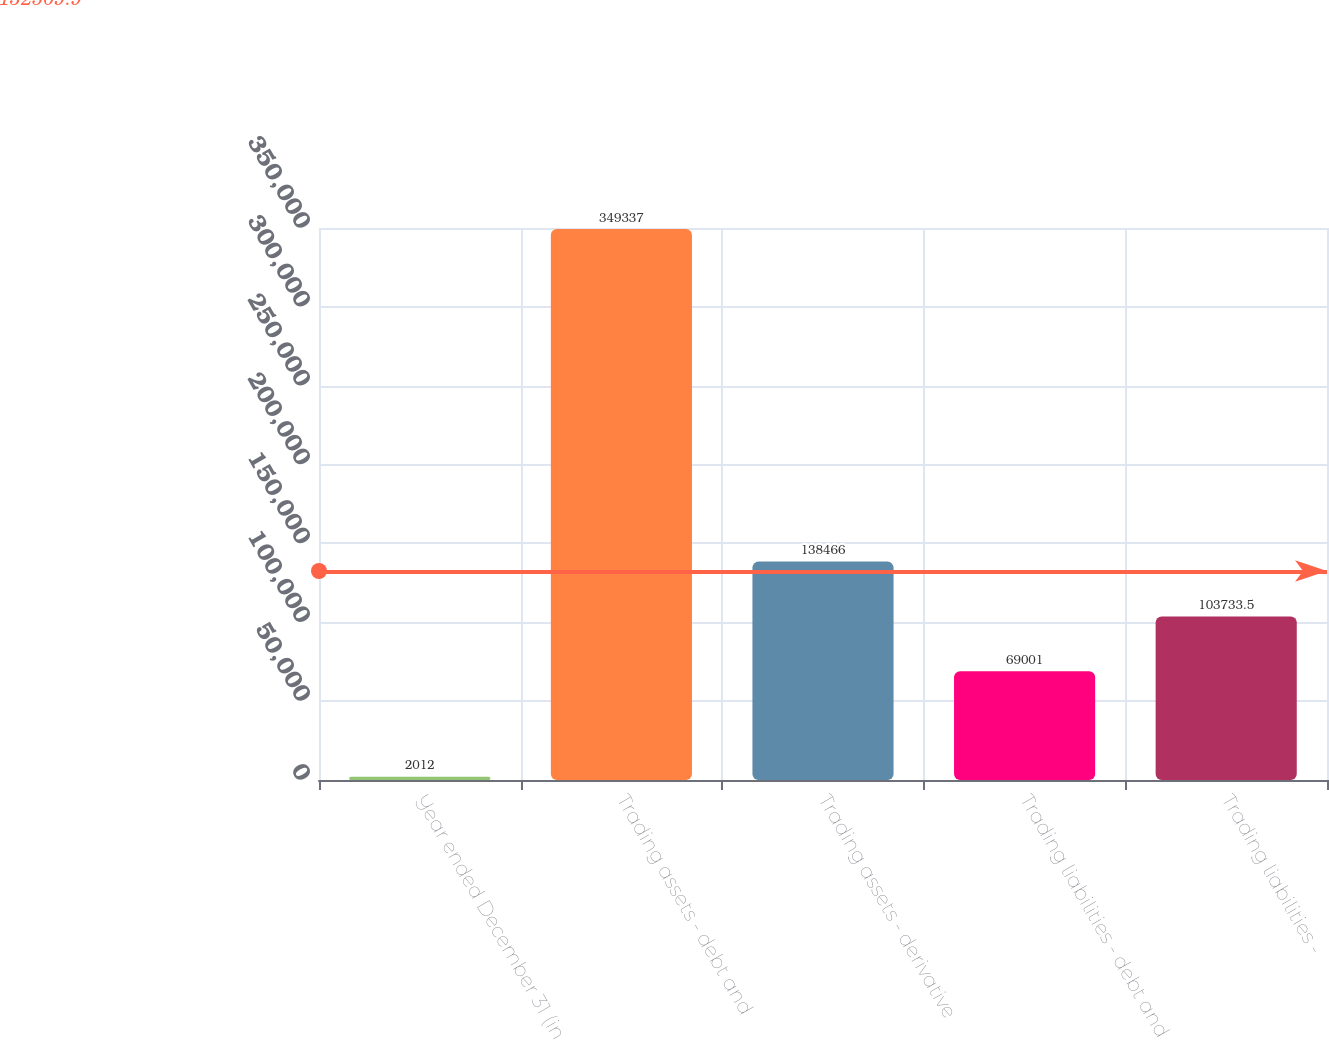<chart> <loc_0><loc_0><loc_500><loc_500><bar_chart><fcel>Year ended December 31 (in<fcel>Trading assets - debt and<fcel>Trading assets - derivative<fcel>Trading liabilities - debt and<fcel>Trading liabilities -<nl><fcel>2012<fcel>349337<fcel>138466<fcel>69001<fcel>103734<nl></chart> 